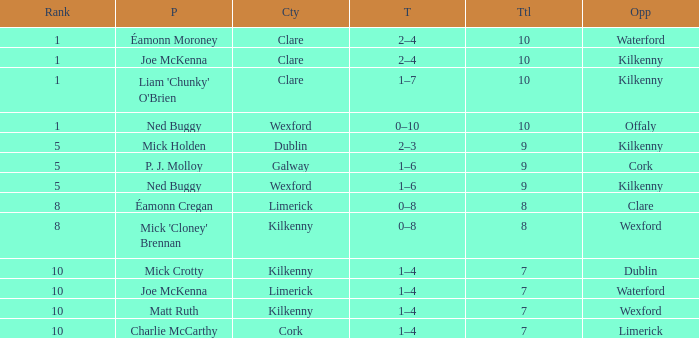Which Total has a County of kilkenny, and a Tally of 1–4, and a Rank larger than 10? None. 